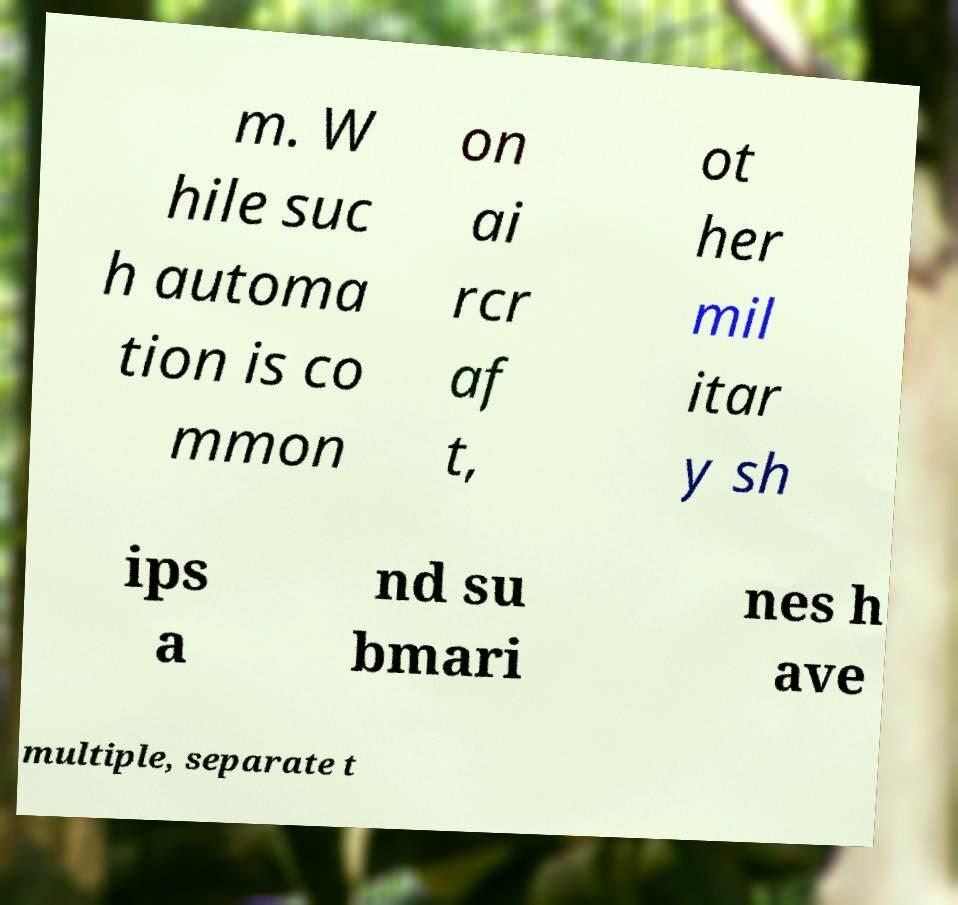Please identify and transcribe the text found in this image. m. W hile suc h automa tion is co mmon on ai rcr af t, ot her mil itar y sh ips a nd su bmari nes h ave multiple, separate t 